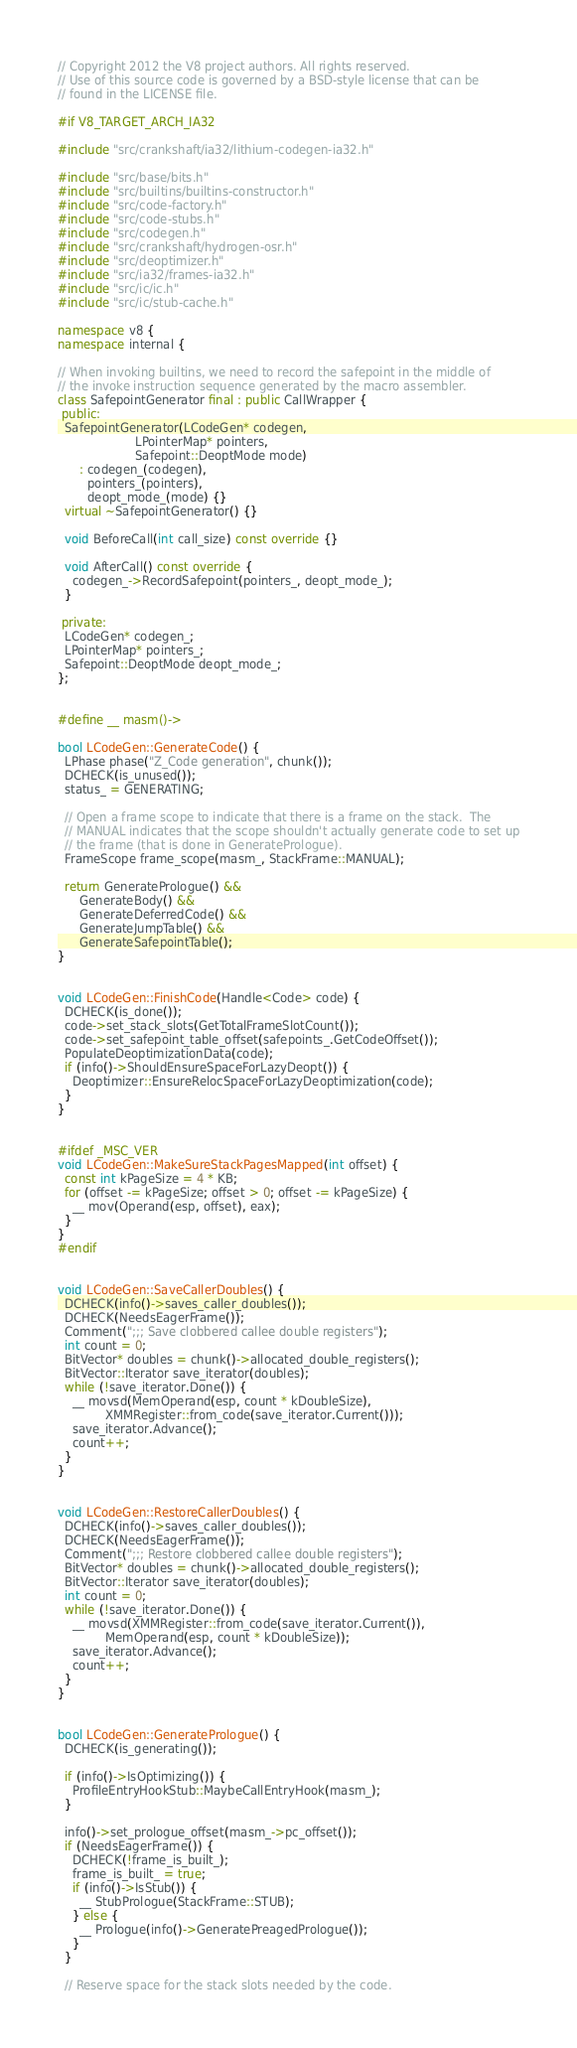Convert code to text. <code><loc_0><loc_0><loc_500><loc_500><_C++_>// Copyright 2012 the V8 project authors. All rights reserved.
// Use of this source code is governed by a BSD-style license that can be
// found in the LICENSE file.

#if V8_TARGET_ARCH_IA32

#include "src/crankshaft/ia32/lithium-codegen-ia32.h"

#include "src/base/bits.h"
#include "src/builtins/builtins-constructor.h"
#include "src/code-factory.h"
#include "src/code-stubs.h"
#include "src/codegen.h"
#include "src/crankshaft/hydrogen-osr.h"
#include "src/deoptimizer.h"
#include "src/ia32/frames-ia32.h"
#include "src/ic/ic.h"
#include "src/ic/stub-cache.h"

namespace v8 {
namespace internal {

// When invoking builtins, we need to record the safepoint in the middle of
// the invoke instruction sequence generated by the macro assembler.
class SafepointGenerator final : public CallWrapper {
 public:
  SafepointGenerator(LCodeGen* codegen,
                     LPointerMap* pointers,
                     Safepoint::DeoptMode mode)
      : codegen_(codegen),
        pointers_(pointers),
        deopt_mode_(mode) {}
  virtual ~SafepointGenerator() {}

  void BeforeCall(int call_size) const override {}

  void AfterCall() const override {
    codegen_->RecordSafepoint(pointers_, deopt_mode_);
  }

 private:
  LCodeGen* codegen_;
  LPointerMap* pointers_;
  Safepoint::DeoptMode deopt_mode_;
};


#define __ masm()->

bool LCodeGen::GenerateCode() {
  LPhase phase("Z_Code generation", chunk());
  DCHECK(is_unused());
  status_ = GENERATING;

  // Open a frame scope to indicate that there is a frame on the stack.  The
  // MANUAL indicates that the scope shouldn't actually generate code to set up
  // the frame (that is done in GeneratePrologue).
  FrameScope frame_scope(masm_, StackFrame::MANUAL);

  return GeneratePrologue() &&
      GenerateBody() &&
      GenerateDeferredCode() &&
      GenerateJumpTable() &&
      GenerateSafepointTable();
}


void LCodeGen::FinishCode(Handle<Code> code) {
  DCHECK(is_done());
  code->set_stack_slots(GetTotalFrameSlotCount());
  code->set_safepoint_table_offset(safepoints_.GetCodeOffset());
  PopulateDeoptimizationData(code);
  if (info()->ShouldEnsureSpaceForLazyDeopt()) {
    Deoptimizer::EnsureRelocSpaceForLazyDeoptimization(code);
  }
}


#ifdef _MSC_VER
void LCodeGen::MakeSureStackPagesMapped(int offset) {
  const int kPageSize = 4 * KB;
  for (offset -= kPageSize; offset > 0; offset -= kPageSize) {
    __ mov(Operand(esp, offset), eax);
  }
}
#endif


void LCodeGen::SaveCallerDoubles() {
  DCHECK(info()->saves_caller_doubles());
  DCHECK(NeedsEagerFrame());
  Comment(";;; Save clobbered callee double registers");
  int count = 0;
  BitVector* doubles = chunk()->allocated_double_registers();
  BitVector::Iterator save_iterator(doubles);
  while (!save_iterator.Done()) {
    __ movsd(MemOperand(esp, count * kDoubleSize),
             XMMRegister::from_code(save_iterator.Current()));
    save_iterator.Advance();
    count++;
  }
}


void LCodeGen::RestoreCallerDoubles() {
  DCHECK(info()->saves_caller_doubles());
  DCHECK(NeedsEagerFrame());
  Comment(";;; Restore clobbered callee double registers");
  BitVector* doubles = chunk()->allocated_double_registers();
  BitVector::Iterator save_iterator(doubles);
  int count = 0;
  while (!save_iterator.Done()) {
    __ movsd(XMMRegister::from_code(save_iterator.Current()),
             MemOperand(esp, count * kDoubleSize));
    save_iterator.Advance();
    count++;
  }
}


bool LCodeGen::GeneratePrologue() {
  DCHECK(is_generating());

  if (info()->IsOptimizing()) {
    ProfileEntryHookStub::MaybeCallEntryHook(masm_);
  }

  info()->set_prologue_offset(masm_->pc_offset());
  if (NeedsEagerFrame()) {
    DCHECK(!frame_is_built_);
    frame_is_built_ = true;
    if (info()->IsStub()) {
      __ StubPrologue(StackFrame::STUB);
    } else {
      __ Prologue(info()->GeneratePreagedPrologue());
    }
  }

  // Reserve space for the stack slots needed by the code.</code> 